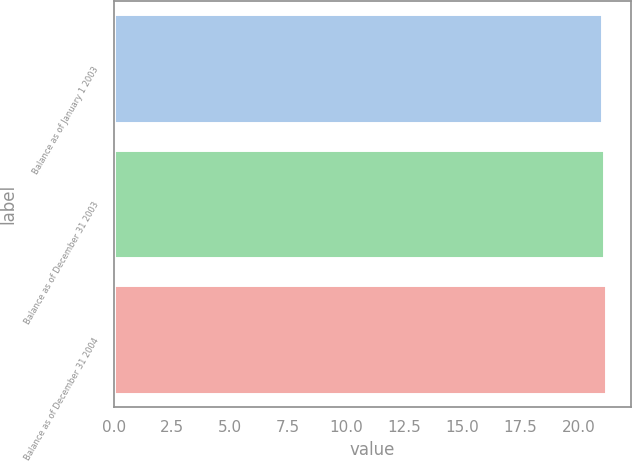<chart> <loc_0><loc_0><loc_500><loc_500><bar_chart><fcel>Balance as of January 1 2003<fcel>Balance as of December 31 2003<fcel>Balance as of December 31 2004<nl><fcel>21<fcel>21.1<fcel>21.2<nl></chart> 